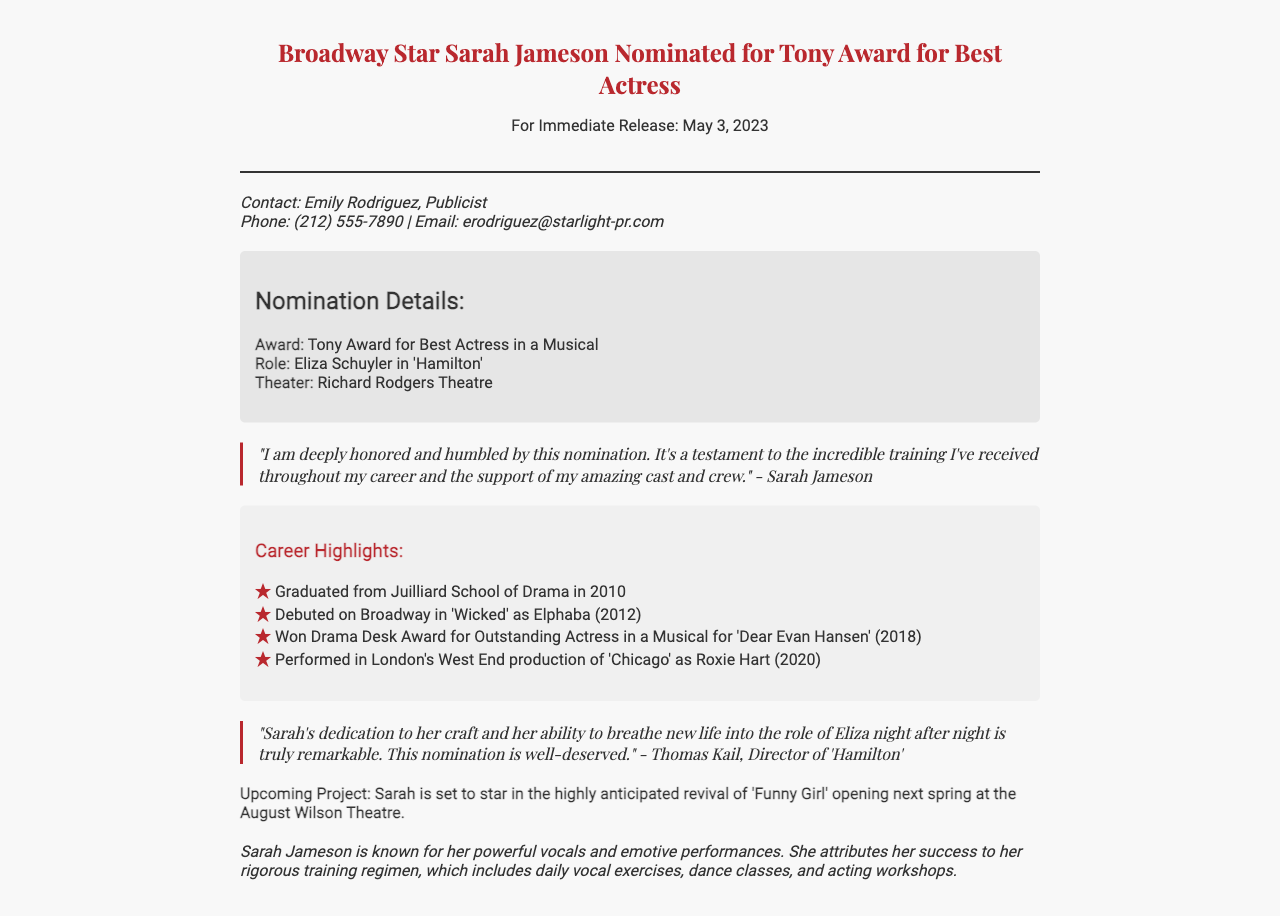What is Sarah Jameson's role in 'Hamilton'? The document states that Sarah Jameson plays the role of Eliza Schuyler in 'Hamilton'.
Answer: Eliza Schuyler When did Sarah graduate from Juilliard School of Drama? The document mentions that Sarah graduated from Juilliard School of Drama in 2010.
Answer: 2010 What award was Sarah Jameson nominated for? According to the document, Sarah Jameson was nominated for the Tony Award for Best Actress in a Musical.
Answer: Tony Award for Best Actress in a Musical What is the title of the upcoming project Sarah is set to star in? The document notes that Sarah is set to star in the revival of 'Funny Girl'.
Answer: Funny Girl Who is the director of 'Hamilton'? The document quotes Thomas Kail as the Director of 'Hamilton'.
Answer: Thomas Kail What year did Sarah make her Broadway debut? The document indicates that Sarah debuted on Broadway in 2012.
Answer: 2012 What did Sarah credit for her success? The document states that Sarah attributes her success to her rigorous training regimen.
Answer: rigorous training regimen How many awards did Sarah win for 'Dear Evan Hansen'? The document indicates that Sarah won one award, the Drama Desk Award for Outstanding Actress in a Musical.
Answer: one What theater is 'Hamilton' performed in? The document says that 'Hamilton' is performed at the Richard Rodgers Theatre.
Answer: Richard Rodgers Theatre 